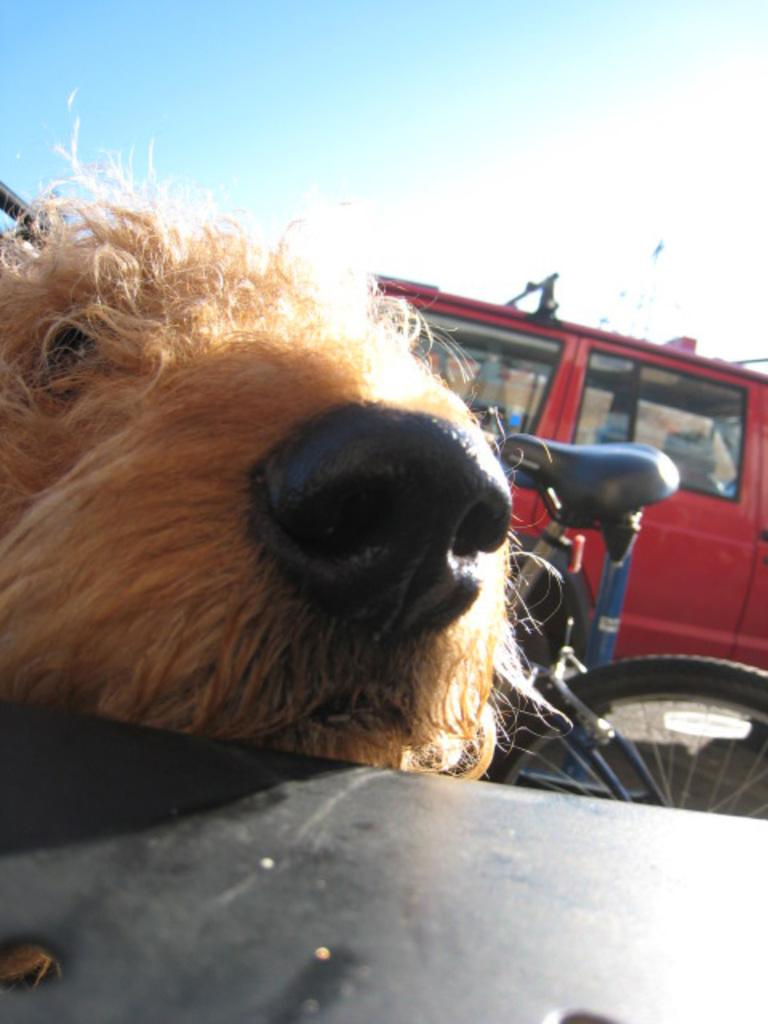What type of animal is in the image? There is a dog in the image. What can be seen in the background of the image? There is a van in the background of the image. What mode of transportation is also present in the image? There is a bicycle in the image. What is located at the bottom of the image? There is a table at the bottom of the image. What is visible at the top of the image? The sky is visible at the top of the image. What type of sand can be seen in the image? There is no sand present in the image. 